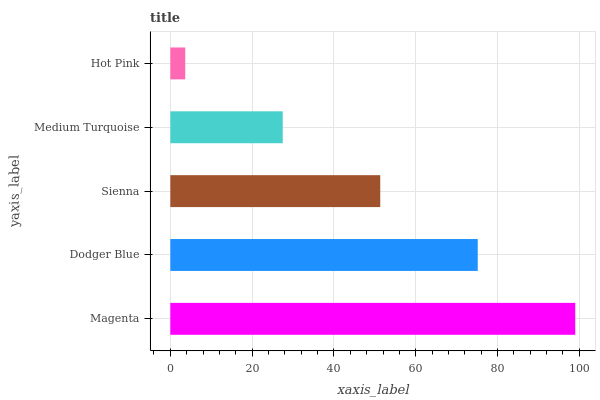Is Hot Pink the minimum?
Answer yes or no. Yes. Is Magenta the maximum?
Answer yes or no. Yes. Is Dodger Blue the minimum?
Answer yes or no. No. Is Dodger Blue the maximum?
Answer yes or no. No. Is Magenta greater than Dodger Blue?
Answer yes or no. Yes. Is Dodger Blue less than Magenta?
Answer yes or no. Yes. Is Dodger Blue greater than Magenta?
Answer yes or no. No. Is Magenta less than Dodger Blue?
Answer yes or no. No. Is Sienna the high median?
Answer yes or no. Yes. Is Sienna the low median?
Answer yes or no. Yes. Is Hot Pink the high median?
Answer yes or no. No. Is Dodger Blue the low median?
Answer yes or no. No. 